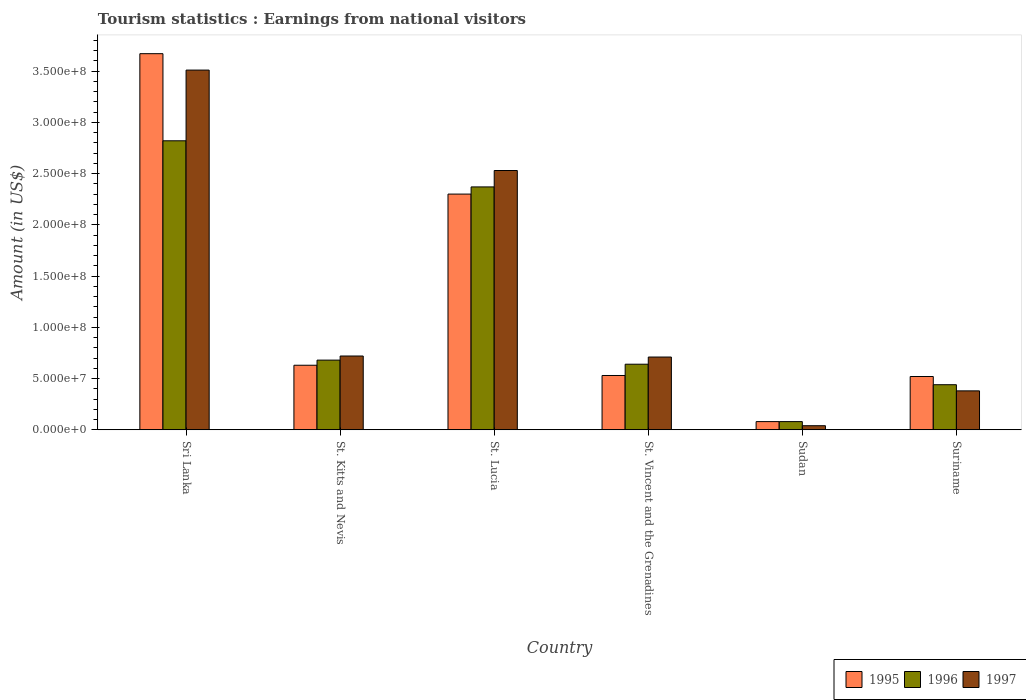How many different coloured bars are there?
Give a very brief answer. 3. How many groups of bars are there?
Ensure brevity in your answer.  6. How many bars are there on the 1st tick from the left?
Offer a very short reply. 3. How many bars are there on the 6th tick from the right?
Your answer should be very brief. 3. What is the label of the 3rd group of bars from the left?
Keep it short and to the point. St. Lucia. What is the earnings from national visitors in 1997 in St. Vincent and the Grenadines?
Give a very brief answer. 7.10e+07. Across all countries, what is the maximum earnings from national visitors in 1995?
Offer a terse response. 3.67e+08. Across all countries, what is the minimum earnings from national visitors in 1995?
Give a very brief answer. 8.00e+06. In which country was the earnings from national visitors in 1996 maximum?
Provide a short and direct response. Sri Lanka. In which country was the earnings from national visitors in 1997 minimum?
Offer a terse response. Sudan. What is the total earnings from national visitors in 1995 in the graph?
Offer a terse response. 7.73e+08. What is the difference between the earnings from national visitors in 1995 in St. Vincent and the Grenadines and that in Suriname?
Make the answer very short. 1.00e+06. What is the difference between the earnings from national visitors in 1995 in St. Lucia and the earnings from national visitors in 1997 in Sudan?
Make the answer very short. 2.26e+08. What is the average earnings from national visitors in 1997 per country?
Provide a succinct answer. 1.32e+08. What is the difference between the earnings from national visitors of/in 1997 and earnings from national visitors of/in 1995 in St. Vincent and the Grenadines?
Your answer should be very brief. 1.80e+07. What is the ratio of the earnings from national visitors in 1995 in St. Vincent and the Grenadines to that in Sudan?
Your response must be concise. 6.62. Is the earnings from national visitors in 1996 in Sri Lanka less than that in St. Vincent and the Grenadines?
Offer a very short reply. No. What is the difference between the highest and the second highest earnings from national visitors in 1995?
Keep it short and to the point. 1.37e+08. What is the difference between the highest and the lowest earnings from national visitors in 1996?
Ensure brevity in your answer.  2.74e+08. What does the 2nd bar from the left in Sudan represents?
Your answer should be very brief. 1996. Is it the case that in every country, the sum of the earnings from national visitors in 1996 and earnings from national visitors in 1995 is greater than the earnings from national visitors in 1997?
Provide a short and direct response. Yes. How many bars are there?
Your answer should be very brief. 18. What is the difference between two consecutive major ticks on the Y-axis?
Provide a short and direct response. 5.00e+07. Does the graph contain grids?
Ensure brevity in your answer.  No. How many legend labels are there?
Keep it short and to the point. 3. How are the legend labels stacked?
Your answer should be very brief. Horizontal. What is the title of the graph?
Give a very brief answer. Tourism statistics : Earnings from national visitors. Does "1981" appear as one of the legend labels in the graph?
Keep it short and to the point. No. What is the label or title of the X-axis?
Provide a succinct answer. Country. What is the Amount (in US$) of 1995 in Sri Lanka?
Give a very brief answer. 3.67e+08. What is the Amount (in US$) in 1996 in Sri Lanka?
Make the answer very short. 2.82e+08. What is the Amount (in US$) in 1997 in Sri Lanka?
Keep it short and to the point. 3.51e+08. What is the Amount (in US$) of 1995 in St. Kitts and Nevis?
Keep it short and to the point. 6.30e+07. What is the Amount (in US$) in 1996 in St. Kitts and Nevis?
Make the answer very short. 6.80e+07. What is the Amount (in US$) of 1997 in St. Kitts and Nevis?
Make the answer very short. 7.20e+07. What is the Amount (in US$) of 1995 in St. Lucia?
Make the answer very short. 2.30e+08. What is the Amount (in US$) in 1996 in St. Lucia?
Provide a short and direct response. 2.37e+08. What is the Amount (in US$) of 1997 in St. Lucia?
Give a very brief answer. 2.53e+08. What is the Amount (in US$) of 1995 in St. Vincent and the Grenadines?
Give a very brief answer. 5.30e+07. What is the Amount (in US$) in 1996 in St. Vincent and the Grenadines?
Make the answer very short. 6.40e+07. What is the Amount (in US$) of 1997 in St. Vincent and the Grenadines?
Offer a very short reply. 7.10e+07. What is the Amount (in US$) in 1995 in Sudan?
Your answer should be compact. 8.00e+06. What is the Amount (in US$) in 1997 in Sudan?
Provide a short and direct response. 4.00e+06. What is the Amount (in US$) of 1995 in Suriname?
Provide a succinct answer. 5.20e+07. What is the Amount (in US$) in 1996 in Suriname?
Ensure brevity in your answer.  4.40e+07. What is the Amount (in US$) in 1997 in Suriname?
Your answer should be compact. 3.80e+07. Across all countries, what is the maximum Amount (in US$) of 1995?
Offer a very short reply. 3.67e+08. Across all countries, what is the maximum Amount (in US$) in 1996?
Your response must be concise. 2.82e+08. Across all countries, what is the maximum Amount (in US$) of 1997?
Your response must be concise. 3.51e+08. Across all countries, what is the minimum Amount (in US$) in 1995?
Provide a short and direct response. 8.00e+06. Across all countries, what is the minimum Amount (in US$) of 1996?
Your response must be concise. 8.00e+06. What is the total Amount (in US$) of 1995 in the graph?
Provide a succinct answer. 7.73e+08. What is the total Amount (in US$) of 1996 in the graph?
Offer a terse response. 7.03e+08. What is the total Amount (in US$) in 1997 in the graph?
Offer a terse response. 7.89e+08. What is the difference between the Amount (in US$) in 1995 in Sri Lanka and that in St. Kitts and Nevis?
Offer a terse response. 3.04e+08. What is the difference between the Amount (in US$) in 1996 in Sri Lanka and that in St. Kitts and Nevis?
Your answer should be compact. 2.14e+08. What is the difference between the Amount (in US$) of 1997 in Sri Lanka and that in St. Kitts and Nevis?
Your response must be concise. 2.79e+08. What is the difference between the Amount (in US$) of 1995 in Sri Lanka and that in St. Lucia?
Your response must be concise. 1.37e+08. What is the difference between the Amount (in US$) in 1996 in Sri Lanka and that in St. Lucia?
Your answer should be very brief. 4.50e+07. What is the difference between the Amount (in US$) in 1997 in Sri Lanka and that in St. Lucia?
Keep it short and to the point. 9.80e+07. What is the difference between the Amount (in US$) in 1995 in Sri Lanka and that in St. Vincent and the Grenadines?
Make the answer very short. 3.14e+08. What is the difference between the Amount (in US$) in 1996 in Sri Lanka and that in St. Vincent and the Grenadines?
Give a very brief answer. 2.18e+08. What is the difference between the Amount (in US$) in 1997 in Sri Lanka and that in St. Vincent and the Grenadines?
Your answer should be compact. 2.80e+08. What is the difference between the Amount (in US$) in 1995 in Sri Lanka and that in Sudan?
Offer a terse response. 3.59e+08. What is the difference between the Amount (in US$) of 1996 in Sri Lanka and that in Sudan?
Offer a terse response. 2.74e+08. What is the difference between the Amount (in US$) in 1997 in Sri Lanka and that in Sudan?
Your response must be concise. 3.47e+08. What is the difference between the Amount (in US$) of 1995 in Sri Lanka and that in Suriname?
Your response must be concise. 3.15e+08. What is the difference between the Amount (in US$) of 1996 in Sri Lanka and that in Suriname?
Offer a very short reply. 2.38e+08. What is the difference between the Amount (in US$) in 1997 in Sri Lanka and that in Suriname?
Provide a succinct answer. 3.13e+08. What is the difference between the Amount (in US$) in 1995 in St. Kitts and Nevis and that in St. Lucia?
Ensure brevity in your answer.  -1.67e+08. What is the difference between the Amount (in US$) in 1996 in St. Kitts and Nevis and that in St. Lucia?
Ensure brevity in your answer.  -1.69e+08. What is the difference between the Amount (in US$) of 1997 in St. Kitts and Nevis and that in St. Lucia?
Your answer should be very brief. -1.81e+08. What is the difference between the Amount (in US$) in 1995 in St. Kitts and Nevis and that in St. Vincent and the Grenadines?
Your answer should be compact. 1.00e+07. What is the difference between the Amount (in US$) of 1996 in St. Kitts and Nevis and that in St. Vincent and the Grenadines?
Give a very brief answer. 4.00e+06. What is the difference between the Amount (in US$) of 1995 in St. Kitts and Nevis and that in Sudan?
Give a very brief answer. 5.50e+07. What is the difference between the Amount (in US$) of 1996 in St. Kitts and Nevis and that in Sudan?
Offer a terse response. 6.00e+07. What is the difference between the Amount (in US$) of 1997 in St. Kitts and Nevis and that in Sudan?
Your response must be concise. 6.80e+07. What is the difference between the Amount (in US$) of 1995 in St. Kitts and Nevis and that in Suriname?
Offer a terse response. 1.10e+07. What is the difference between the Amount (in US$) in 1996 in St. Kitts and Nevis and that in Suriname?
Provide a short and direct response. 2.40e+07. What is the difference between the Amount (in US$) of 1997 in St. Kitts and Nevis and that in Suriname?
Offer a terse response. 3.40e+07. What is the difference between the Amount (in US$) of 1995 in St. Lucia and that in St. Vincent and the Grenadines?
Offer a very short reply. 1.77e+08. What is the difference between the Amount (in US$) of 1996 in St. Lucia and that in St. Vincent and the Grenadines?
Provide a succinct answer. 1.73e+08. What is the difference between the Amount (in US$) in 1997 in St. Lucia and that in St. Vincent and the Grenadines?
Keep it short and to the point. 1.82e+08. What is the difference between the Amount (in US$) in 1995 in St. Lucia and that in Sudan?
Your answer should be compact. 2.22e+08. What is the difference between the Amount (in US$) of 1996 in St. Lucia and that in Sudan?
Provide a succinct answer. 2.29e+08. What is the difference between the Amount (in US$) in 1997 in St. Lucia and that in Sudan?
Make the answer very short. 2.49e+08. What is the difference between the Amount (in US$) in 1995 in St. Lucia and that in Suriname?
Your answer should be very brief. 1.78e+08. What is the difference between the Amount (in US$) in 1996 in St. Lucia and that in Suriname?
Provide a succinct answer. 1.93e+08. What is the difference between the Amount (in US$) of 1997 in St. Lucia and that in Suriname?
Your answer should be compact. 2.15e+08. What is the difference between the Amount (in US$) in 1995 in St. Vincent and the Grenadines and that in Sudan?
Provide a succinct answer. 4.50e+07. What is the difference between the Amount (in US$) in 1996 in St. Vincent and the Grenadines and that in Sudan?
Ensure brevity in your answer.  5.60e+07. What is the difference between the Amount (in US$) in 1997 in St. Vincent and the Grenadines and that in Sudan?
Provide a succinct answer. 6.70e+07. What is the difference between the Amount (in US$) in 1996 in St. Vincent and the Grenadines and that in Suriname?
Your response must be concise. 2.00e+07. What is the difference between the Amount (in US$) of 1997 in St. Vincent and the Grenadines and that in Suriname?
Give a very brief answer. 3.30e+07. What is the difference between the Amount (in US$) of 1995 in Sudan and that in Suriname?
Keep it short and to the point. -4.40e+07. What is the difference between the Amount (in US$) of 1996 in Sudan and that in Suriname?
Your answer should be compact. -3.60e+07. What is the difference between the Amount (in US$) in 1997 in Sudan and that in Suriname?
Your answer should be compact. -3.40e+07. What is the difference between the Amount (in US$) in 1995 in Sri Lanka and the Amount (in US$) in 1996 in St. Kitts and Nevis?
Your response must be concise. 2.99e+08. What is the difference between the Amount (in US$) of 1995 in Sri Lanka and the Amount (in US$) of 1997 in St. Kitts and Nevis?
Provide a succinct answer. 2.95e+08. What is the difference between the Amount (in US$) of 1996 in Sri Lanka and the Amount (in US$) of 1997 in St. Kitts and Nevis?
Offer a very short reply. 2.10e+08. What is the difference between the Amount (in US$) of 1995 in Sri Lanka and the Amount (in US$) of 1996 in St. Lucia?
Your answer should be very brief. 1.30e+08. What is the difference between the Amount (in US$) in 1995 in Sri Lanka and the Amount (in US$) in 1997 in St. Lucia?
Keep it short and to the point. 1.14e+08. What is the difference between the Amount (in US$) in 1996 in Sri Lanka and the Amount (in US$) in 1997 in St. Lucia?
Provide a succinct answer. 2.90e+07. What is the difference between the Amount (in US$) of 1995 in Sri Lanka and the Amount (in US$) of 1996 in St. Vincent and the Grenadines?
Offer a very short reply. 3.03e+08. What is the difference between the Amount (in US$) in 1995 in Sri Lanka and the Amount (in US$) in 1997 in St. Vincent and the Grenadines?
Give a very brief answer. 2.96e+08. What is the difference between the Amount (in US$) of 1996 in Sri Lanka and the Amount (in US$) of 1997 in St. Vincent and the Grenadines?
Offer a very short reply. 2.11e+08. What is the difference between the Amount (in US$) of 1995 in Sri Lanka and the Amount (in US$) of 1996 in Sudan?
Make the answer very short. 3.59e+08. What is the difference between the Amount (in US$) in 1995 in Sri Lanka and the Amount (in US$) in 1997 in Sudan?
Make the answer very short. 3.63e+08. What is the difference between the Amount (in US$) in 1996 in Sri Lanka and the Amount (in US$) in 1997 in Sudan?
Offer a terse response. 2.78e+08. What is the difference between the Amount (in US$) in 1995 in Sri Lanka and the Amount (in US$) in 1996 in Suriname?
Offer a very short reply. 3.23e+08. What is the difference between the Amount (in US$) of 1995 in Sri Lanka and the Amount (in US$) of 1997 in Suriname?
Make the answer very short. 3.29e+08. What is the difference between the Amount (in US$) of 1996 in Sri Lanka and the Amount (in US$) of 1997 in Suriname?
Ensure brevity in your answer.  2.44e+08. What is the difference between the Amount (in US$) of 1995 in St. Kitts and Nevis and the Amount (in US$) of 1996 in St. Lucia?
Provide a succinct answer. -1.74e+08. What is the difference between the Amount (in US$) in 1995 in St. Kitts and Nevis and the Amount (in US$) in 1997 in St. Lucia?
Provide a succinct answer. -1.90e+08. What is the difference between the Amount (in US$) of 1996 in St. Kitts and Nevis and the Amount (in US$) of 1997 in St. Lucia?
Provide a succinct answer. -1.85e+08. What is the difference between the Amount (in US$) in 1995 in St. Kitts and Nevis and the Amount (in US$) in 1997 in St. Vincent and the Grenadines?
Ensure brevity in your answer.  -8.00e+06. What is the difference between the Amount (in US$) of 1996 in St. Kitts and Nevis and the Amount (in US$) of 1997 in St. Vincent and the Grenadines?
Ensure brevity in your answer.  -3.00e+06. What is the difference between the Amount (in US$) in 1995 in St. Kitts and Nevis and the Amount (in US$) in 1996 in Sudan?
Your answer should be very brief. 5.50e+07. What is the difference between the Amount (in US$) of 1995 in St. Kitts and Nevis and the Amount (in US$) of 1997 in Sudan?
Give a very brief answer. 5.90e+07. What is the difference between the Amount (in US$) in 1996 in St. Kitts and Nevis and the Amount (in US$) in 1997 in Sudan?
Your answer should be very brief. 6.40e+07. What is the difference between the Amount (in US$) in 1995 in St. Kitts and Nevis and the Amount (in US$) in 1996 in Suriname?
Offer a terse response. 1.90e+07. What is the difference between the Amount (in US$) in 1995 in St. Kitts and Nevis and the Amount (in US$) in 1997 in Suriname?
Give a very brief answer. 2.50e+07. What is the difference between the Amount (in US$) in 1996 in St. Kitts and Nevis and the Amount (in US$) in 1997 in Suriname?
Ensure brevity in your answer.  3.00e+07. What is the difference between the Amount (in US$) in 1995 in St. Lucia and the Amount (in US$) in 1996 in St. Vincent and the Grenadines?
Provide a short and direct response. 1.66e+08. What is the difference between the Amount (in US$) in 1995 in St. Lucia and the Amount (in US$) in 1997 in St. Vincent and the Grenadines?
Keep it short and to the point. 1.59e+08. What is the difference between the Amount (in US$) in 1996 in St. Lucia and the Amount (in US$) in 1997 in St. Vincent and the Grenadines?
Provide a succinct answer. 1.66e+08. What is the difference between the Amount (in US$) of 1995 in St. Lucia and the Amount (in US$) of 1996 in Sudan?
Keep it short and to the point. 2.22e+08. What is the difference between the Amount (in US$) of 1995 in St. Lucia and the Amount (in US$) of 1997 in Sudan?
Give a very brief answer. 2.26e+08. What is the difference between the Amount (in US$) of 1996 in St. Lucia and the Amount (in US$) of 1997 in Sudan?
Provide a short and direct response. 2.33e+08. What is the difference between the Amount (in US$) in 1995 in St. Lucia and the Amount (in US$) in 1996 in Suriname?
Make the answer very short. 1.86e+08. What is the difference between the Amount (in US$) of 1995 in St. Lucia and the Amount (in US$) of 1997 in Suriname?
Provide a short and direct response. 1.92e+08. What is the difference between the Amount (in US$) of 1996 in St. Lucia and the Amount (in US$) of 1997 in Suriname?
Keep it short and to the point. 1.99e+08. What is the difference between the Amount (in US$) in 1995 in St. Vincent and the Grenadines and the Amount (in US$) in 1996 in Sudan?
Provide a succinct answer. 4.50e+07. What is the difference between the Amount (in US$) in 1995 in St. Vincent and the Grenadines and the Amount (in US$) in 1997 in Sudan?
Provide a short and direct response. 4.90e+07. What is the difference between the Amount (in US$) in 1996 in St. Vincent and the Grenadines and the Amount (in US$) in 1997 in Sudan?
Provide a succinct answer. 6.00e+07. What is the difference between the Amount (in US$) in 1995 in St. Vincent and the Grenadines and the Amount (in US$) in 1996 in Suriname?
Offer a terse response. 9.00e+06. What is the difference between the Amount (in US$) of 1995 in St. Vincent and the Grenadines and the Amount (in US$) of 1997 in Suriname?
Give a very brief answer. 1.50e+07. What is the difference between the Amount (in US$) in 1996 in St. Vincent and the Grenadines and the Amount (in US$) in 1997 in Suriname?
Provide a short and direct response. 2.60e+07. What is the difference between the Amount (in US$) in 1995 in Sudan and the Amount (in US$) in 1996 in Suriname?
Your response must be concise. -3.60e+07. What is the difference between the Amount (in US$) in 1995 in Sudan and the Amount (in US$) in 1997 in Suriname?
Offer a terse response. -3.00e+07. What is the difference between the Amount (in US$) in 1996 in Sudan and the Amount (in US$) in 1997 in Suriname?
Ensure brevity in your answer.  -3.00e+07. What is the average Amount (in US$) of 1995 per country?
Provide a succinct answer. 1.29e+08. What is the average Amount (in US$) in 1996 per country?
Provide a short and direct response. 1.17e+08. What is the average Amount (in US$) of 1997 per country?
Ensure brevity in your answer.  1.32e+08. What is the difference between the Amount (in US$) of 1995 and Amount (in US$) of 1996 in Sri Lanka?
Offer a terse response. 8.50e+07. What is the difference between the Amount (in US$) in 1995 and Amount (in US$) in 1997 in Sri Lanka?
Your response must be concise. 1.60e+07. What is the difference between the Amount (in US$) of 1996 and Amount (in US$) of 1997 in Sri Lanka?
Give a very brief answer. -6.90e+07. What is the difference between the Amount (in US$) of 1995 and Amount (in US$) of 1996 in St. Kitts and Nevis?
Your answer should be compact. -5.00e+06. What is the difference between the Amount (in US$) in 1995 and Amount (in US$) in 1997 in St. Kitts and Nevis?
Give a very brief answer. -9.00e+06. What is the difference between the Amount (in US$) of 1996 and Amount (in US$) of 1997 in St. Kitts and Nevis?
Keep it short and to the point. -4.00e+06. What is the difference between the Amount (in US$) of 1995 and Amount (in US$) of 1996 in St. Lucia?
Ensure brevity in your answer.  -7.00e+06. What is the difference between the Amount (in US$) in 1995 and Amount (in US$) in 1997 in St. Lucia?
Offer a terse response. -2.30e+07. What is the difference between the Amount (in US$) of 1996 and Amount (in US$) of 1997 in St. Lucia?
Offer a terse response. -1.60e+07. What is the difference between the Amount (in US$) of 1995 and Amount (in US$) of 1996 in St. Vincent and the Grenadines?
Your answer should be very brief. -1.10e+07. What is the difference between the Amount (in US$) of 1995 and Amount (in US$) of 1997 in St. Vincent and the Grenadines?
Keep it short and to the point. -1.80e+07. What is the difference between the Amount (in US$) of 1996 and Amount (in US$) of 1997 in St. Vincent and the Grenadines?
Provide a succinct answer. -7.00e+06. What is the difference between the Amount (in US$) in 1996 and Amount (in US$) in 1997 in Sudan?
Provide a short and direct response. 4.00e+06. What is the difference between the Amount (in US$) in 1995 and Amount (in US$) in 1996 in Suriname?
Provide a short and direct response. 8.00e+06. What is the difference between the Amount (in US$) of 1995 and Amount (in US$) of 1997 in Suriname?
Give a very brief answer. 1.40e+07. What is the ratio of the Amount (in US$) of 1995 in Sri Lanka to that in St. Kitts and Nevis?
Provide a succinct answer. 5.83. What is the ratio of the Amount (in US$) in 1996 in Sri Lanka to that in St. Kitts and Nevis?
Offer a very short reply. 4.15. What is the ratio of the Amount (in US$) in 1997 in Sri Lanka to that in St. Kitts and Nevis?
Your answer should be compact. 4.88. What is the ratio of the Amount (in US$) of 1995 in Sri Lanka to that in St. Lucia?
Offer a very short reply. 1.6. What is the ratio of the Amount (in US$) of 1996 in Sri Lanka to that in St. Lucia?
Provide a succinct answer. 1.19. What is the ratio of the Amount (in US$) of 1997 in Sri Lanka to that in St. Lucia?
Make the answer very short. 1.39. What is the ratio of the Amount (in US$) in 1995 in Sri Lanka to that in St. Vincent and the Grenadines?
Make the answer very short. 6.92. What is the ratio of the Amount (in US$) in 1996 in Sri Lanka to that in St. Vincent and the Grenadines?
Your answer should be very brief. 4.41. What is the ratio of the Amount (in US$) of 1997 in Sri Lanka to that in St. Vincent and the Grenadines?
Your answer should be compact. 4.94. What is the ratio of the Amount (in US$) in 1995 in Sri Lanka to that in Sudan?
Give a very brief answer. 45.88. What is the ratio of the Amount (in US$) of 1996 in Sri Lanka to that in Sudan?
Offer a very short reply. 35.25. What is the ratio of the Amount (in US$) of 1997 in Sri Lanka to that in Sudan?
Your answer should be very brief. 87.75. What is the ratio of the Amount (in US$) in 1995 in Sri Lanka to that in Suriname?
Give a very brief answer. 7.06. What is the ratio of the Amount (in US$) of 1996 in Sri Lanka to that in Suriname?
Your response must be concise. 6.41. What is the ratio of the Amount (in US$) of 1997 in Sri Lanka to that in Suriname?
Your answer should be compact. 9.24. What is the ratio of the Amount (in US$) in 1995 in St. Kitts and Nevis to that in St. Lucia?
Give a very brief answer. 0.27. What is the ratio of the Amount (in US$) of 1996 in St. Kitts and Nevis to that in St. Lucia?
Make the answer very short. 0.29. What is the ratio of the Amount (in US$) in 1997 in St. Kitts and Nevis to that in St. Lucia?
Offer a terse response. 0.28. What is the ratio of the Amount (in US$) of 1995 in St. Kitts and Nevis to that in St. Vincent and the Grenadines?
Make the answer very short. 1.19. What is the ratio of the Amount (in US$) in 1997 in St. Kitts and Nevis to that in St. Vincent and the Grenadines?
Make the answer very short. 1.01. What is the ratio of the Amount (in US$) in 1995 in St. Kitts and Nevis to that in Sudan?
Provide a short and direct response. 7.88. What is the ratio of the Amount (in US$) of 1996 in St. Kitts and Nevis to that in Sudan?
Provide a short and direct response. 8.5. What is the ratio of the Amount (in US$) in 1997 in St. Kitts and Nevis to that in Sudan?
Offer a terse response. 18. What is the ratio of the Amount (in US$) of 1995 in St. Kitts and Nevis to that in Suriname?
Your answer should be very brief. 1.21. What is the ratio of the Amount (in US$) of 1996 in St. Kitts and Nevis to that in Suriname?
Give a very brief answer. 1.55. What is the ratio of the Amount (in US$) in 1997 in St. Kitts and Nevis to that in Suriname?
Provide a short and direct response. 1.89. What is the ratio of the Amount (in US$) in 1995 in St. Lucia to that in St. Vincent and the Grenadines?
Your answer should be compact. 4.34. What is the ratio of the Amount (in US$) in 1996 in St. Lucia to that in St. Vincent and the Grenadines?
Give a very brief answer. 3.7. What is the ratio of the Amount (in US$) in 1997 in St. Lucia to that in St. Vincent and the Grenadines?
Your answer should be compact. 3.56. What is the ratio of the Amount (in US$) in 1995 in St. Lucia to that in Sudan?
Make the answer very short. 28.75. What is the ratio of the Amount (in US$) of 1996 in St. Lucia to that in Sudan?
Offer a terse response. 29.62. What is the ratio of the Amount (in US$) in 1997 in St. Lucia to that in Sudan?
Your response must be concise. 63.25. What is the ratio of the Amount (in US$) in 1995 in St. Lucia to that in Suriname?
Provide a short and direct response. 4.42. What is the ratio of the Amount (in US$) in 1996 in St. Lucia to that in Suriname?
Your answer should be compact. 5.39. What is the ratio of the Amount (in US$) in 1997 in St. Lucia to that in Suriname?
Offer a terse response. 6.66. What is the ratio of the Amount (in US$) of 1995 in St. Vincent and the Grenadines to that in Sudan?
Provide a succinct answer. 6.62. What is the ratio of the Amount (in US$) of 1996 in St. Vincent and the Grenadines to that in Sudan?
Your answer should be very brief. 8. What is the ratio of the Amount (in US$) of 1997 in St. Vincent and the Grenadines to that in Sudan?
Offer a terse response. 17.75. What is the ratio of the Amount (in US$) of 1995 in St. Vincent and the Grenadines to that in Suriname?
Keep it short and to the point. 1.02. What is the ratio of the Amount (in US$) in 1996 in St. Vincent and the Grenadines to that in Suriname?
Keep it short and to the point. 1.45. What is the ratio of the Amount (in US$) in 1997 in St. Vincent and the Grenadines to that in Suriname?
Make the answer very short. 1.87. What is the ratio of the Amount (in US$) of 1995 in Sudan to that in Suriname?
Keep it short and to the point. 0.15. What is the ratio of the Amount (in US$) in 1996 in Sudan to that in Suriname?
Provide a short and direct response. 0.18. What is the ratio of the Amount (in US$) of 1997 in Sudan to that in Suriname?
Give a very brief answer. 0.11. What is the difference between the highest and the second highest Amount (in US$) in 1995?
Your response must be concise. 1.37e+08. What is the difference between the highest and the second highest Amount (in US$) in 1996?
Your answer should be very brief. 4.50e+07. What is the difference between the highest and the second highest Amount (in US$) in 1997?
Give a very brief answer. 9.80e+07. What is the difference between the highest and the lowest Amount (in US$) of 1995?
Give a very brief answer. 3.59e+08. What is the difference between the highest and the lowest Amount (in US$) of 1996?
Ensure brevity in your answer.  2.74e+08. What is the difference between the highest and the lowest Amount (in US$) of 1997?
Offer a terse response. 3.47e+08. 